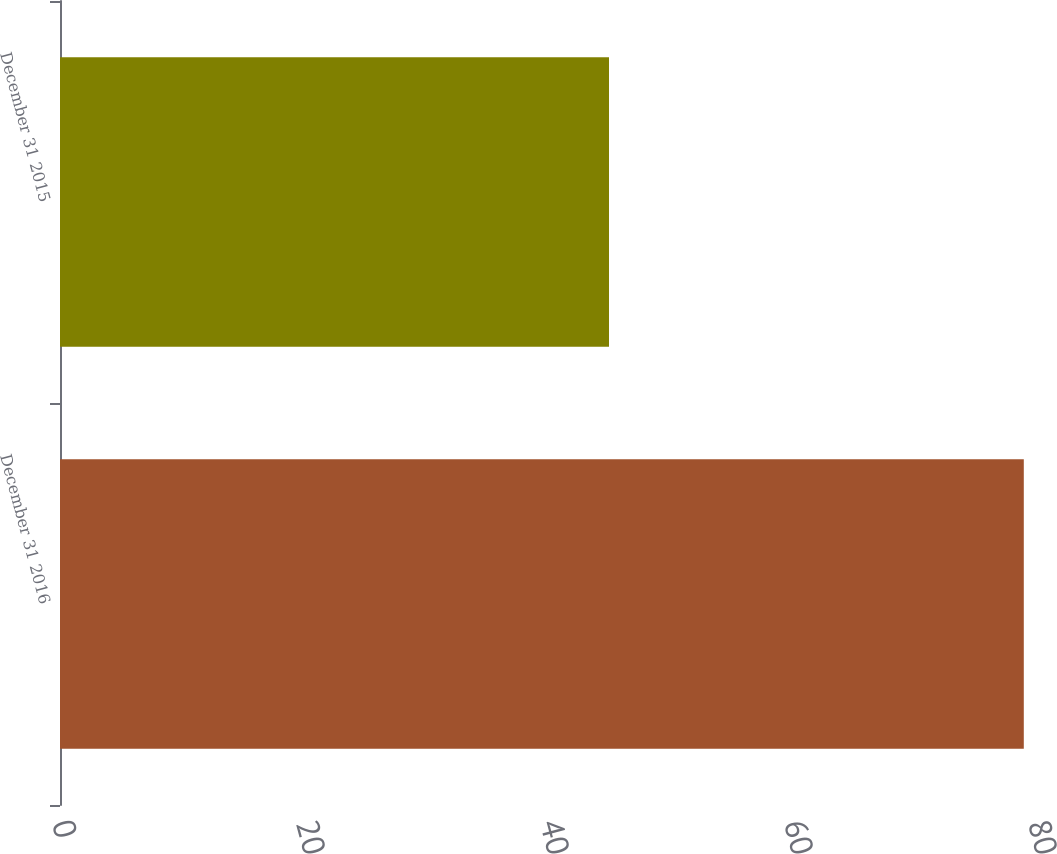Convert chart to OTSL. <chart><loc_0><loc_0><loc_500><loc_500><bar_chart><fcel>December 31 2016<fcel>December 31 2015<nl><fcel>79<fcel>45<nl></chart> 